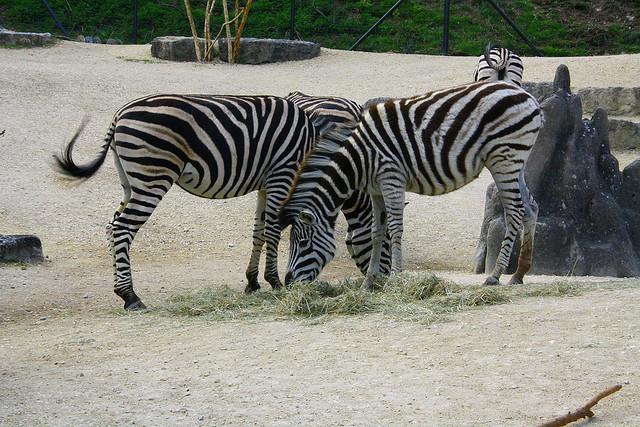What setting are these animals in?
Answer briefly. Zoo. How many zebras are at the zoo?
Keep it brief. 3. How many zebras are shown?
Quick response, please. 3. Are the zebras wild or in a zoo?
Write a very short answer. Zoo. Are they eating?
Concise answer only. Yes. Are the zebras friendly?
Quick response, please. Yes. Which is the tallest animal in the photo?
Keep it brief. Zebra. 